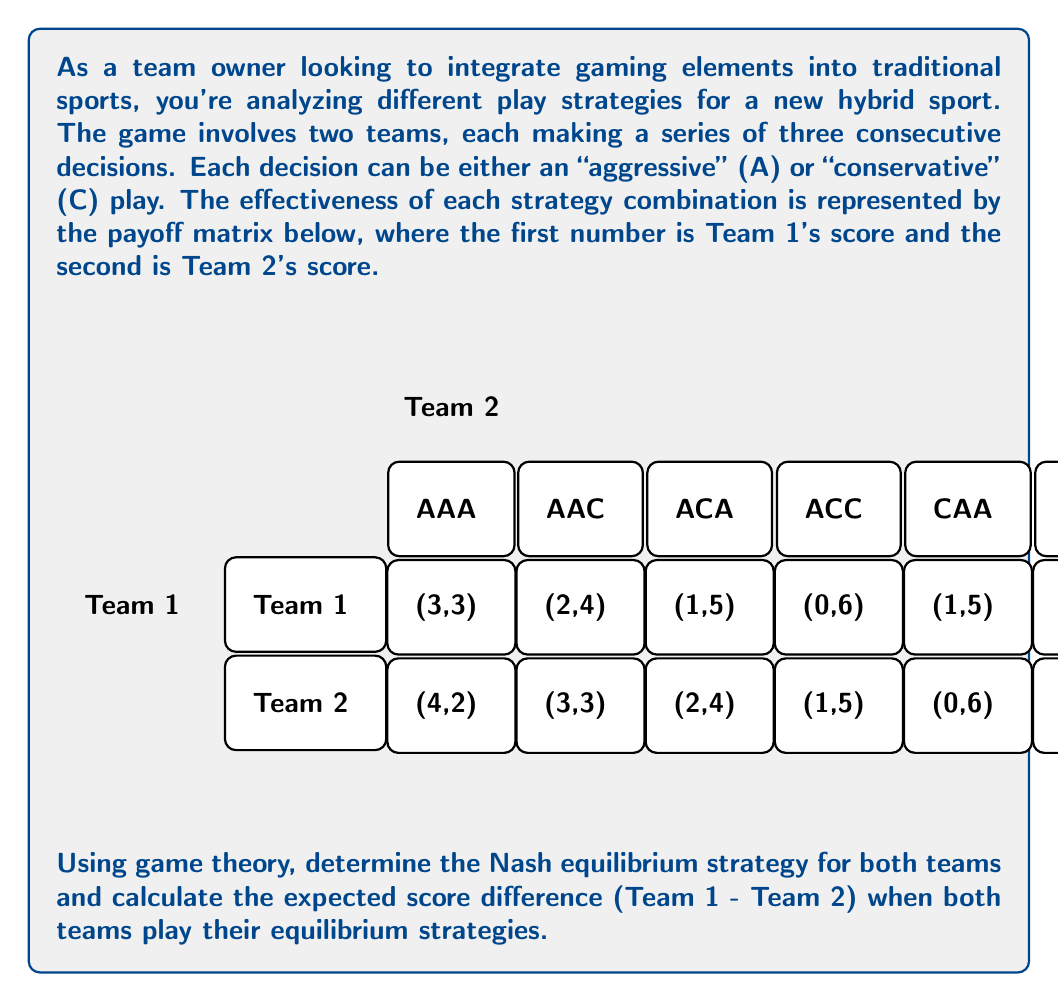Can you answer this question? To solve this problem, we'll follow these steps:

1) Identify dominated strategies
2) Find the best response for each team to the other's strategies
3) Determine the Nash equilibrium
4) Calculate the expected score difference

Step 1: Identify dominated strategies

For Team 1:
- AAA dominates AAC, ACA, and ACC
- CCC dominates CAA, CAC, and CCA

For Team 2:
- AAA dominates AAC, ACA, and ACC
- CCC dominates CAA, CAC, and CCA

We can now focus on the reduced payoff matrix:

$$
\begin{array}{c|cc}
 & \text{AAA} & \text{CCC} \\
\hline
\text{AAA} & (3,3) & (4,2) \\
\text{CCC} & (4,2) & (3,3)
\end{array}
$$

Step 2: Find best responses

For Team 1:
- If Team 2 plays AAA, Team 1's best response is CCC (4 > 3)
- If Team 2 plays CCC, Team 1's best response is AAA (4 > 3)

For Team 2:
- If Team 1 plays AAA, Team 2's best response is AAA (3 > 2)
- If Team 1 plays CCC, Team 2's best response is CCC (3 > 2)

Step 3: Determine Nash equilibrium

There are two pure strategy Nash equilibria:
1) (CCC, AAA)
2) (AAA, CCC)

There's also a mixed strategy equilibrium. Let's find it:

Let $p$ be the probability of Team 1 playing AAA, and $q$ be the probability of Team 2 playing AAA.

For Team 1 to be indifferent:
$$3q + 4(1-q) = 4q + 3(1-q)$$
$$3q + 4 - 4q = 4q + 3 - 3q$$
$$4 - q = q + 3$$
$$1 = 2q$$
$$q = 0.5$$

Similarly, for Team 2:
$$3p + 4(1-p) = 4p + 3(1-p)$$
$$p = 0.5$$

Therefore, the mixed strategy Nash equilibrium is (0.5AAA + 0.5CCC, 0.5AAA + 0.5CCC).

Step 4: Calculate expected score difference

In the mixed strategy equilibrium:

Team 1's expected score:
$$0.5 \cdot 0.5 \cdot 3 + 0.5 \cdot 0.5 \cdot 4 + 0.5 \cdot 0.5 \cdot 4 + 0.5 \cdot 0.5 \cdot 3 = 3.5$$

Team 2's expected score:
$$0.5 \cdot 0.5 \cdot 3 + 0.5 \cdot 0.5 \cdot 2 + 0.5 \cdot 0.5 \cdot 2 + 0.5 \cdot 0.5 \cdot 3 = 2.5$$

Expected score difference (Team 1 - Team 2) = 3.5 - 2.5 = 1
Answer: 1 